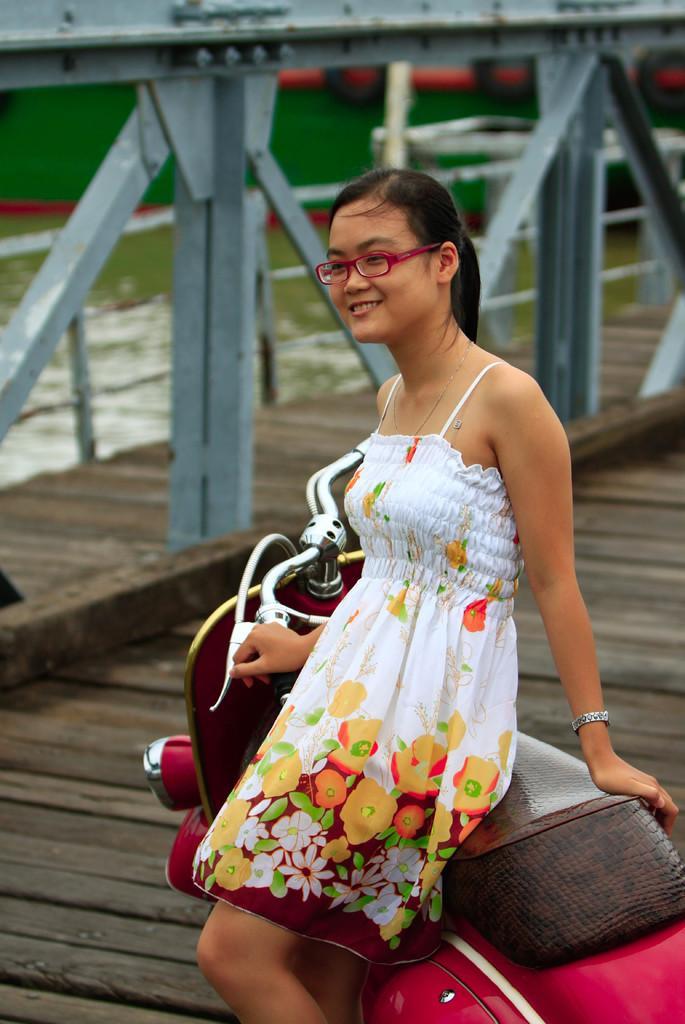Can you describe this image briefly? The girl in white dress is sitting on the red color scooter. She is wearing spectacles and she is smiling. Behind her, we see iron rods. In the background, we see a green color wall. 